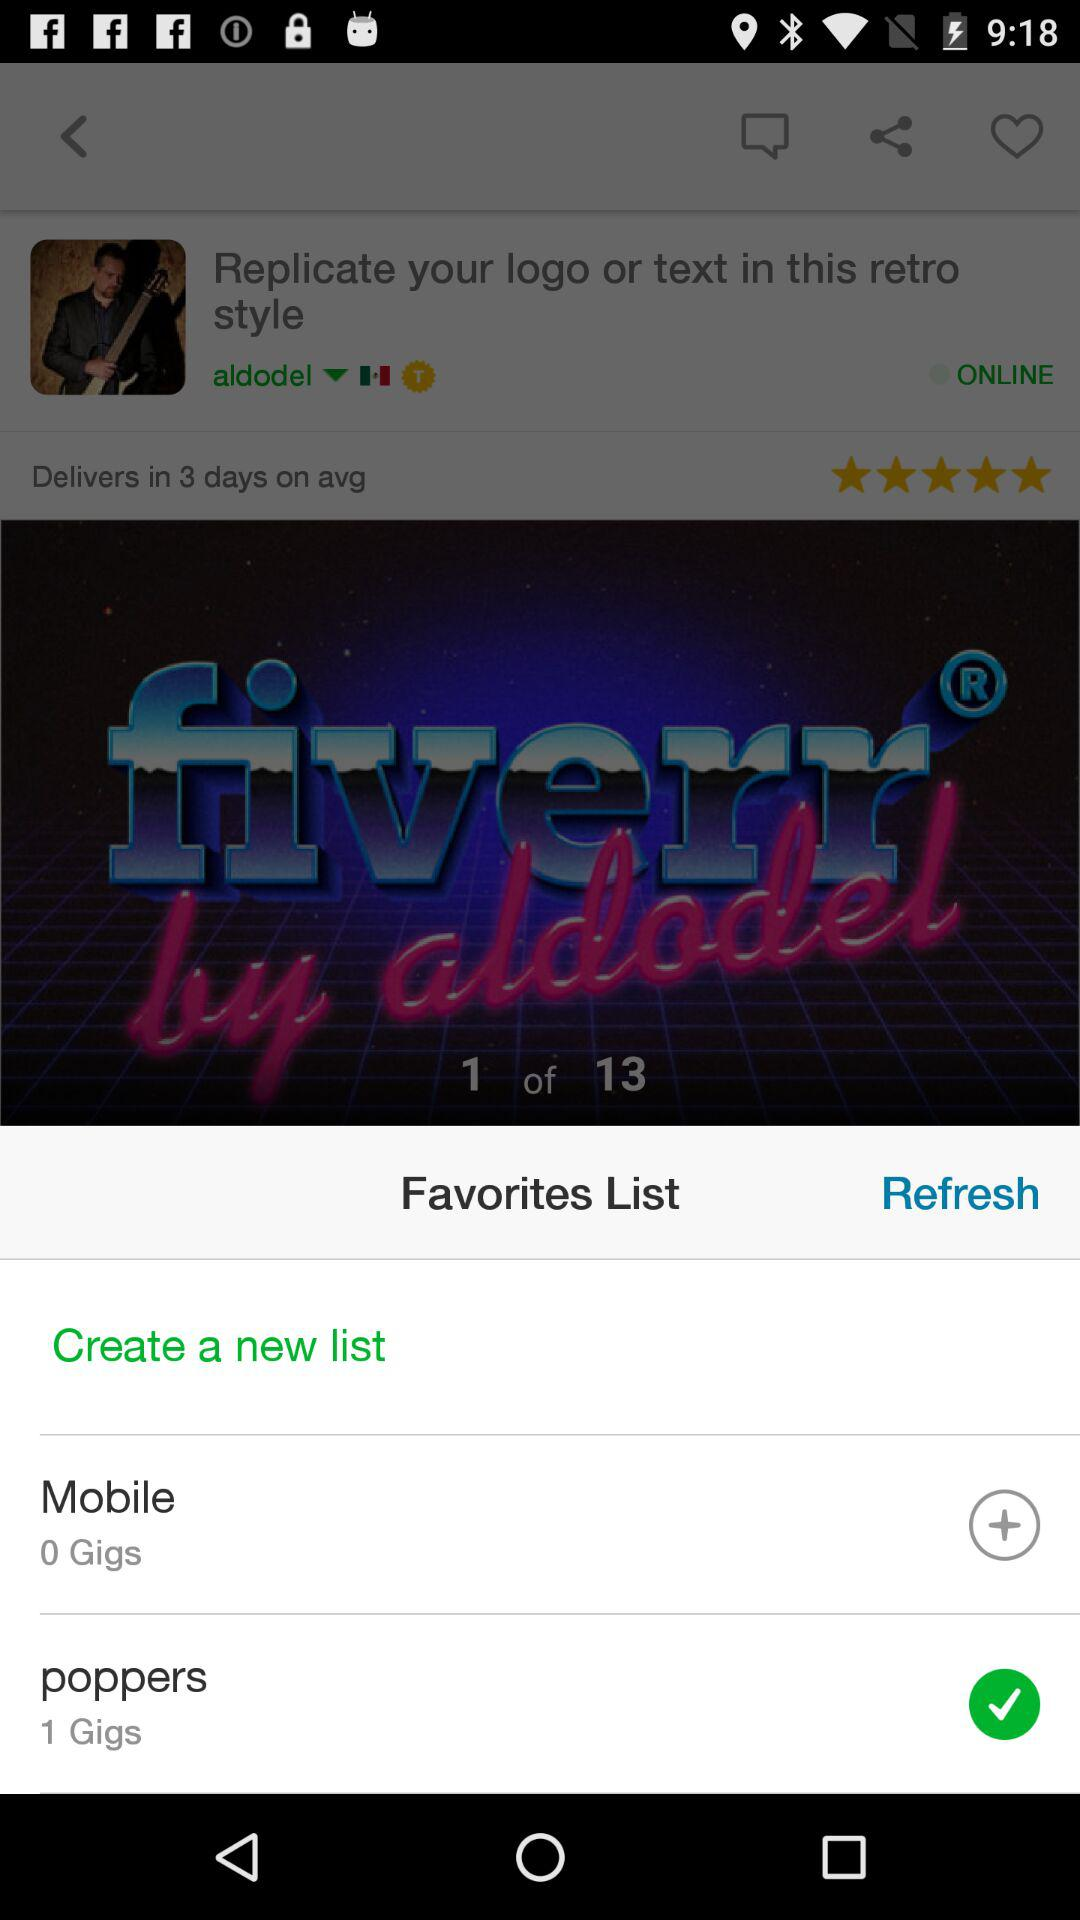What image am I at? You are on image 1. 